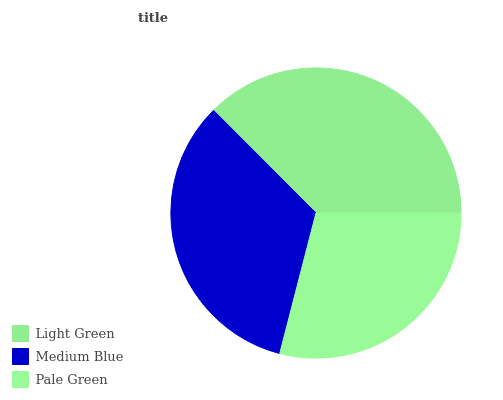Is Pale Green the minimum?
Answer yes or no. Yes. Is Light Green the maximum?
Answer yes or no. Yes. Is Medium Blue the minimum?
Answer yes or no. No. Is Medium Blue the maximum?
Answer yes or no. No. Is Light Green greater than Medium Blue?
Answer yes or no. Yes. Is Medium Blue less than Light Green?
Answer yes or no. Yes. Is Medium Blue greater than Light Green?
Answer yes or no. No. Is Light Green less than Medium Blue?
Answer yes or no. No. Is Medium Blue the high median?
Answer yes or no. Yes. Is Medium Blue the low median?
Answer yes or no. Yes. Is Light Green the high median?
Answer yes or no. No. Is Light Green the low median?
Answer yes or no. No. 